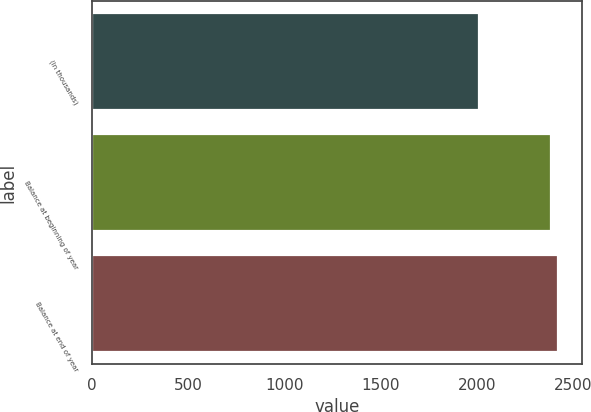Convert chart to OTSL. <chart><loc_0><loc_0><loc_500><loc_500><bar_chart><fcel>(In thousands)<fcel>Balance at beginning of year<fcel>Balance at end of year<nl><fcel>2013<fcel>2385<fcel>2422.2<nl></chart> 